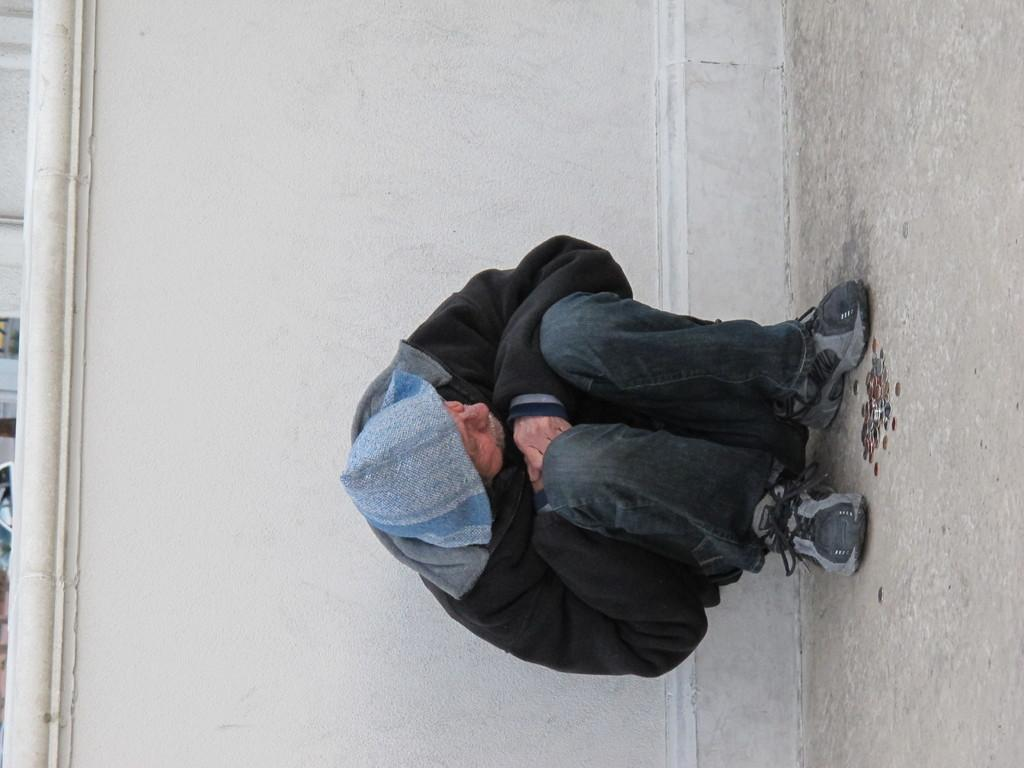How is the image oriented? The image appears to be rotated towards the right. What is the position of the old person in the image? The old person is sitting on the floor. What is behind the old person in the image? There is a wall behind the old person. What is on the floor in front of the old person? There are coins on the floor before the old person. What type of lunchroom can be seen in the image? There is no lunchroom present in the image. How much does the old person weigh in the image? The weight of the old person cannot be determined from the image. 